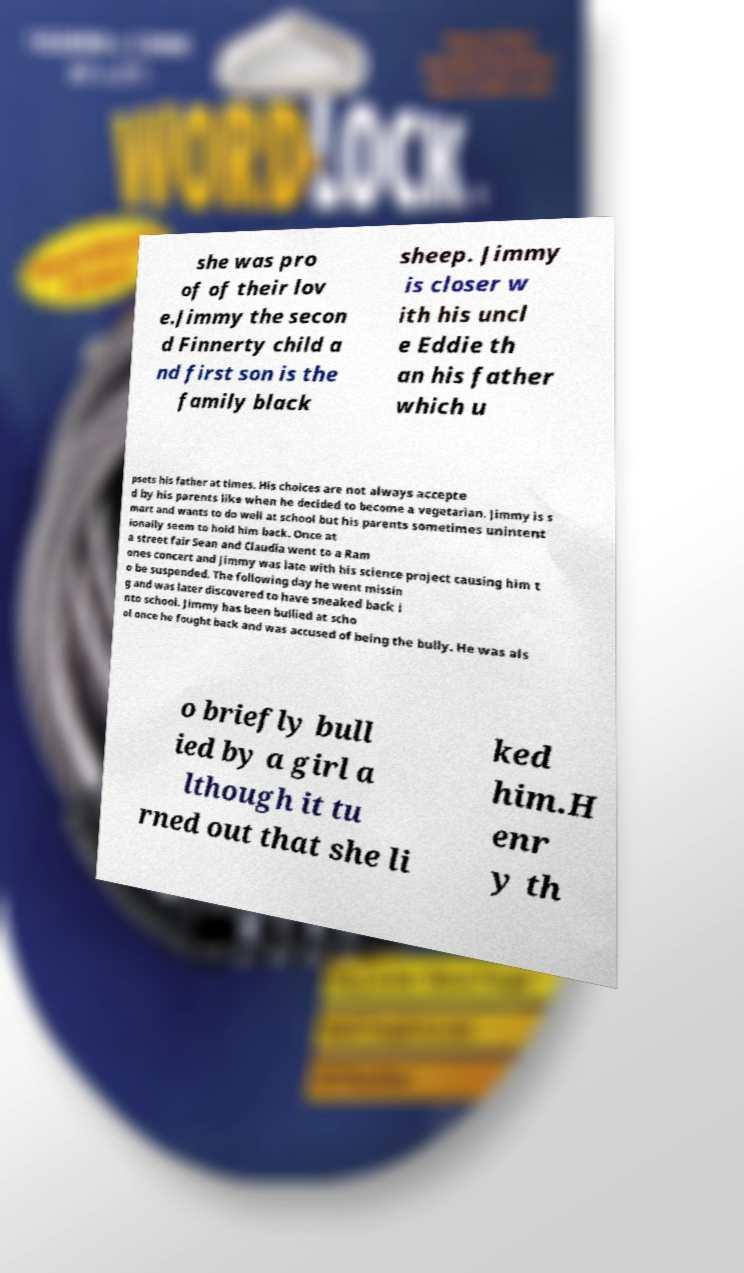I need the written content from this picture converted into text. Can you do that? she was pro of of their lov e.Jimmy the secon d Finnerty child a nd first son is the family black sheep. Jimmy is closer w ith his uncl e Eddie th an his father which u psets his father at times. His choices are not always accepte d by his parents like when he decided to become a vegetarian. Jimmy is s mart and wants to do well at school but his parents sometimes unintent ionally seem to hold him back. Once at a street fair Sean and Claudia went to a Ram ones concert and Jimmy was late with his science project causing him t o be suspended. The following day he went missin g and was later discovered to have sneaked back i nto school. Jimmy has been bullied at scho ol once he fought back and was accused of being the bully. He was als o briefly bull ied by a girl a lthough it tu rned out that she li ked him.H enr y th 